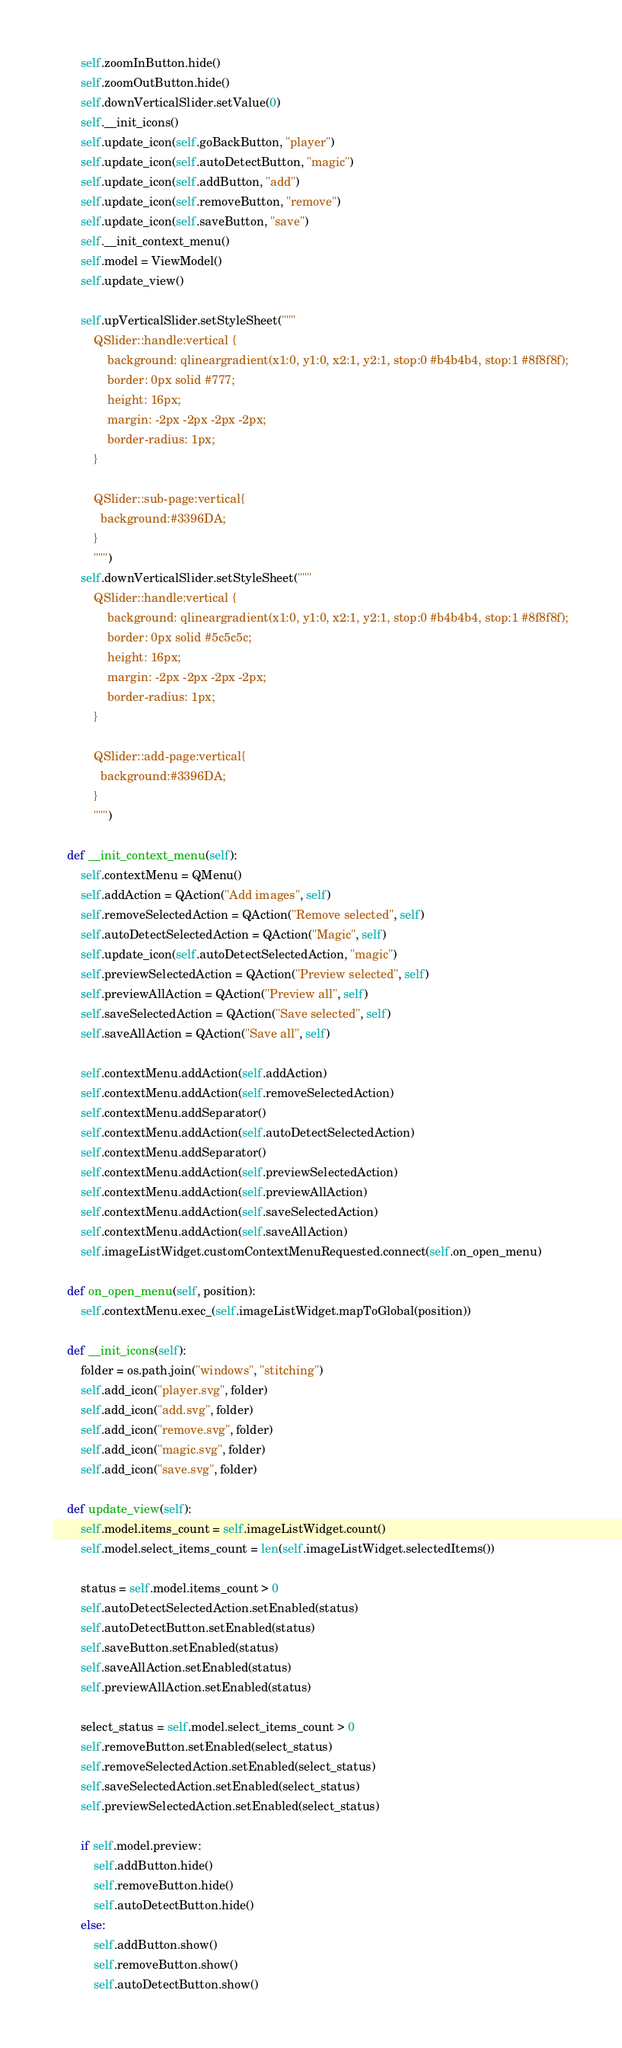Convert code to text. <code><loc_0><loc_0><loc_500><loc_500><_Python_>        self.zoomInButton.hide()
        self.zoomOutButton.hide()
        self.downVerticalSlider.setValue(0)
        self.__init_icons()
        self.update_icon(self.goBackButton, "player")
        self.update_icon(self.autoDetectButton, "magic")
        self.update_icon(self.addButton, "add")
        self.update_icon(self.removeButton, "remove")
        self.update_icon(self.saveButton, "save")
        self.__init_context_menu()
        self.model = ViewModel()
        self.update_view()

        self.upVerticalSlider.setStyleSheet("""
            QSlider::handle:vertical {
                background: qlineargradient(x1:0, y1:0, x2:1, y2:1, stop:0 #b4b4b4, stop:1 #8f8f8f);
                border: 0px solid #777;
                height: 16px;
                margin: -2px -2px -2px -2px;
                border-radius: 1px;
            }

            QSlider::sub-page:vertical{
              background:#3396DA;
            }
            """)
        self.downVerticalSlider.setStyleSheet("""
            QSlider::handle:vertical {
                background: qlineargradient(x1:0, y1:0, x2:1, y2:1, stop:0 #b4b4b4, stop:1 #8f8f8f);
                border: 0px solid #5c5c5c;
                height: 16px;
                margin: -2px -2px -2px -2px;
                border-radius: 1px;
            }
    
            QSlider::add-page:vertical{
              background:#3396DA;
            }
            """)

    def __init_context_menu(self):
        self.contextMenu = QMenu()
        self.addAction = QAction("Add images", self)
        self.removeSelectedAction = QAction("Remove selected", self)
        self.autoDetectSelectedAction = QAction("Magic", self)
        self.update_icon(self.autoDetectSelectedAction, "magic")
        self.previewSelectedAction = QAction("Preview selected", self)
        self.previewAllAction = QAction("Preview all", self)
        self.saveSelectedAction = QAction("Save selected", self)
        self.saveAllAction = QAction("Save all", self)

        self.contextMenu.addAction(self.addAction)
        self.contextMenu.addAction(self.removeSelectedAction)
        self.contextMenu.addSeparator()
        self.contextMenu.addAction(self.autoDetectSelectedAction)
        self.contextMenu.addSeparator()
        self.contextMenu.addAction(self.previewSelectedAction)
        self.contextMenu.addAction(self.previewAllAction)
        self.contextMenu.addAction(self.saveSelectedAction)
        self.contextMenu.addAction(self.saveAllAction)
        self.imageListWidget.customContextMenuRequested.connect(self.on_open_menu)

    def on_open_menu(self, position):
        self.contextMenu.exec_(self.imageListWidget.mapToGlobal(position))

    def __init_icons(self):
        folder = os.path.join("windows", "stitching")
        self.add_icon("player.svg", folder)
        self.add_icon("add.svg", folder)
        self.add_icon("remove.svg", folder)
        self.add_icon("magic.svg", folder)
        self.add_icon("save.svg", folder)

    def update_view(self):
        self.model.items_count = self.imageListWidget.count()
        self.model.select_items_count = len(self.imageListWidget.selectedItems())

        status = self.model.items_count > 0
        self.autoDetectSelectedAction.setEnabled(status)
        self.autoDetectButton.setEnabled(status)
        self.saveButton.setEnabled(status)
        self.saveAllAction.setEnabled(status)
        self.previewAllAction.setEnabled(status)

        select_status = self.model.select_items_count > 0
        self.removeButton.setEnabled(select_status)
        self.removeSelectedAction.setEnabled(select_status)
        self.saveSelectedAction.setEnabled(select_status)
        self.previewSelectedAction.setEnabled(select_status)

        if self.model.preview:
            self.addButton.hide()
            self.removeButton.hide()
            self.autoDetectButton.hide()
        else:
            self.addButton.show()
            self.removeButton.show()
            self.autoDetectButton.show()
</code> 